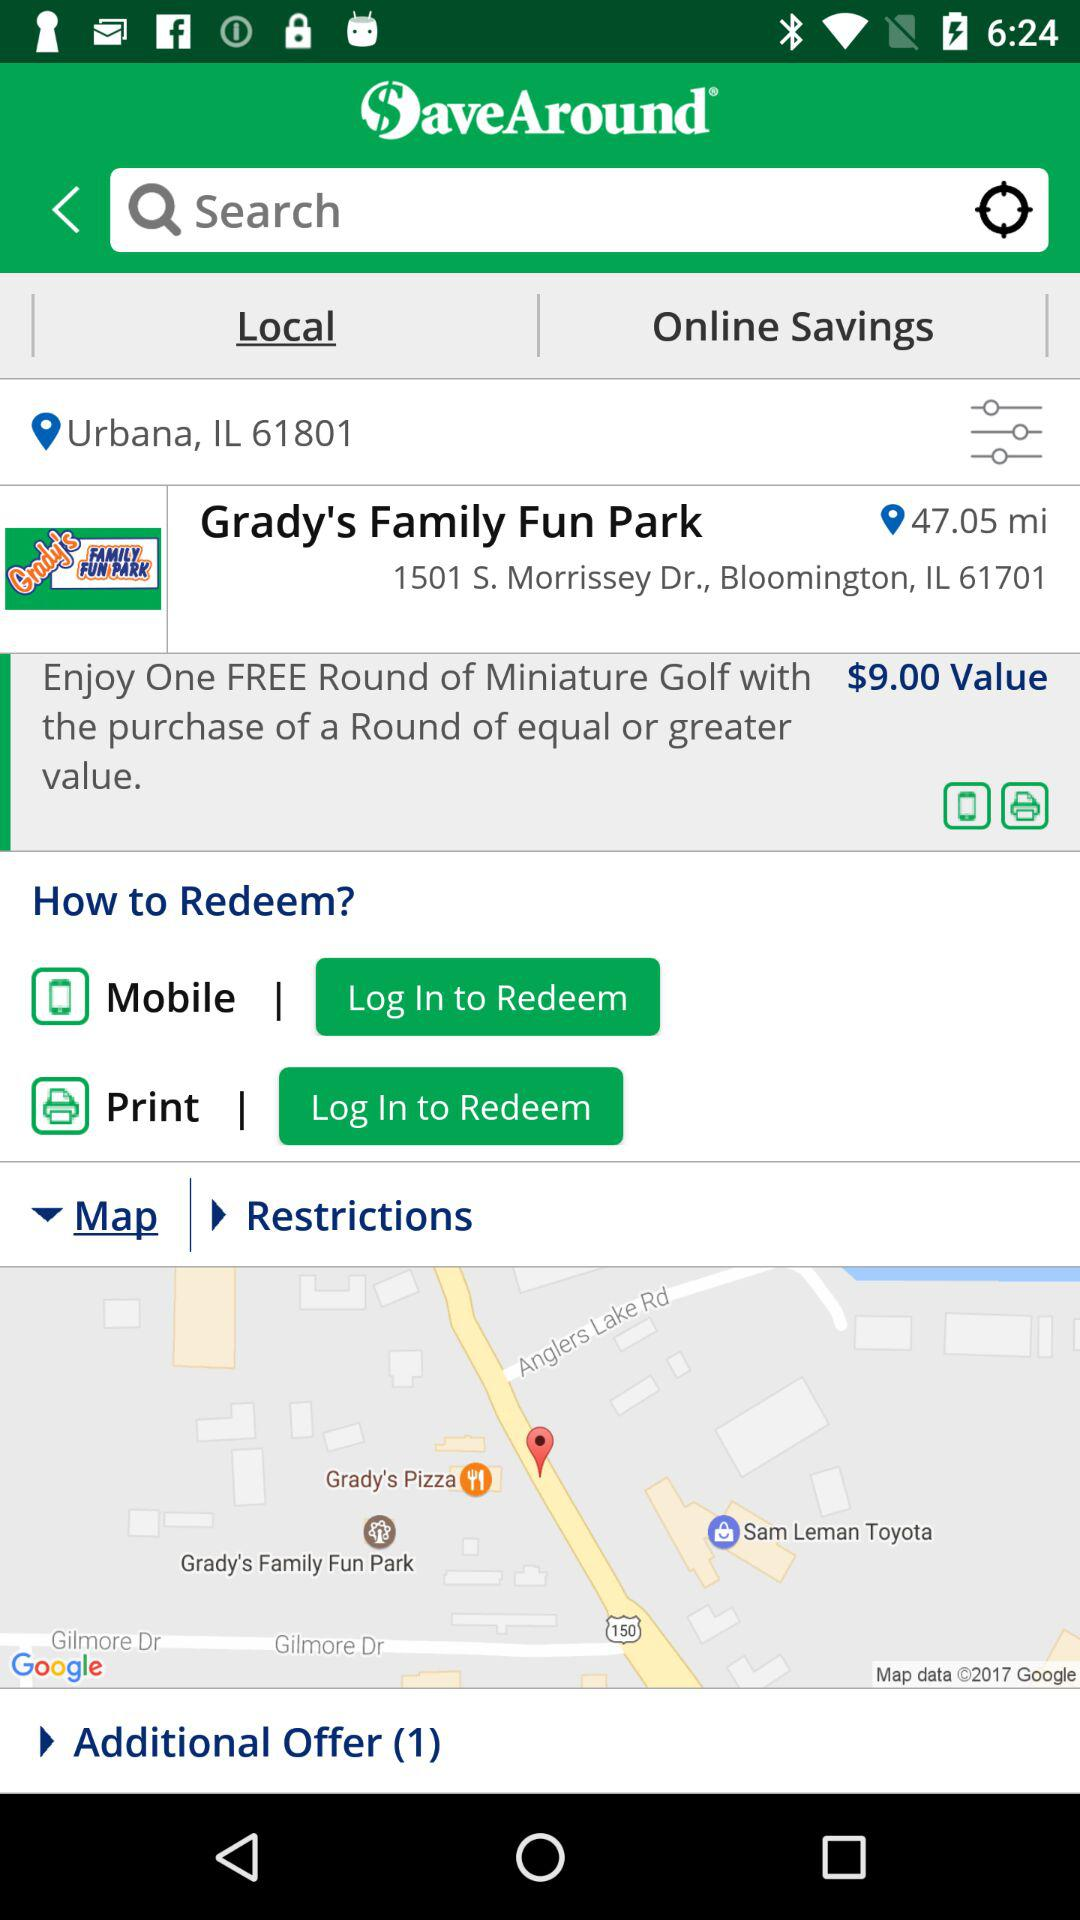What is the number of additional offers? The number is 1. 